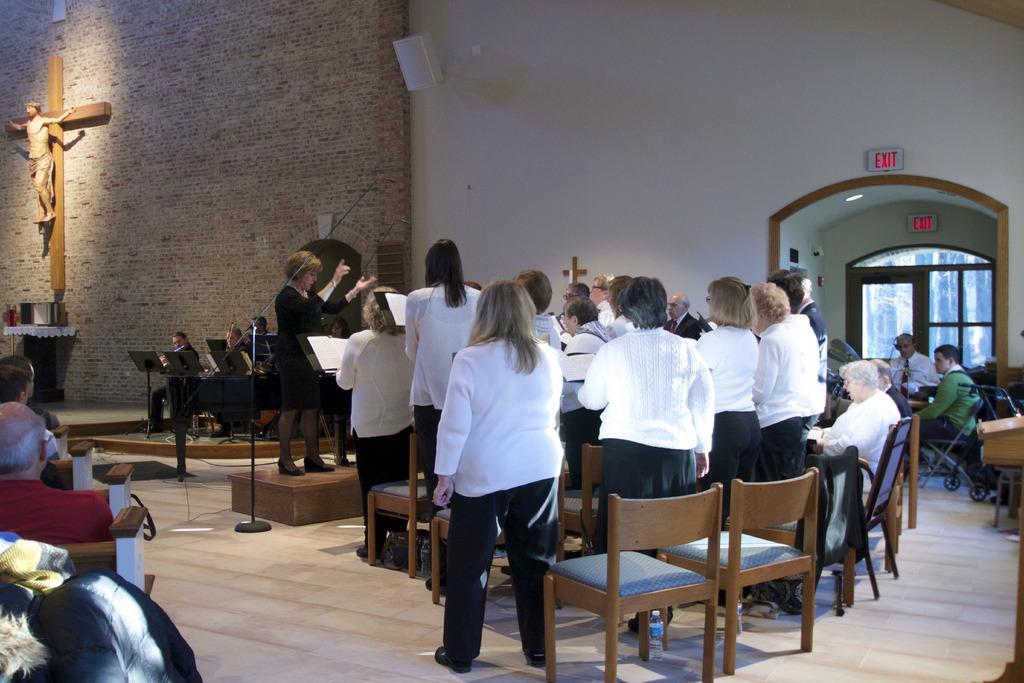How would you summarize this image in a sentence or two? This picture shows a group of people standing and few are seated on the chairs and we see a woman standing 